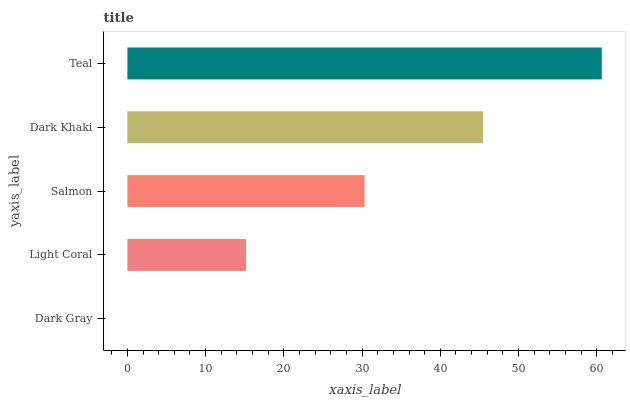Is Dark Gray the minimum?
Answer yes or no. Yes. Is Teal the maximum?
Answer yes or no. Yes. Is Light Coral the minimum?
Answer yes or no. No. Is Light Coral the maximum?
Answer yes or no. No. Is Light Coral greater than Dark Gray?
Answer yes or no. Yes. Is Dark Gray less than Light Coral?
Answer yes or no. Yes. Is Dark Gray greater than Light Coral?
Answer yes or no. No. Is Light Coral less than Dark Gray?
Answer yes or no. No. Is Salmon the high median?
Answer yes or no. Yes. Is Salmon the low median?
Answer yes or no. Yes. Is Dark Khaki the high median?
Answer yes or no. No. Is Light Coral the low median?
Answer yes or no. No. 